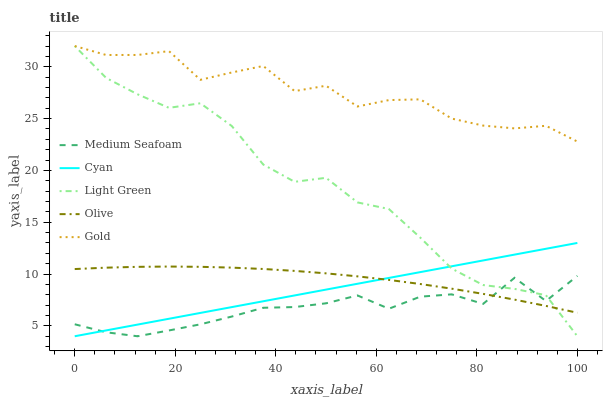Does Cyan have the minimum area under the curve?
Answer yes or no. No. Does Cyan have the maximum area under the curve?
Answer yes or no. No. Is Gold the smoothest?
Answer yes or no. No. Is Cyan the roughest?
Answer yes or no. No. Does Gold have the lowest value?
Answer yes or no. No. Does Cyan have the highest value?
Answer yes or no. No. Is Olive less than Gold?
Answer yes or no. Yes. Is Gold greater than Cyan?
Answer yes or no. Yes. Does Olive intersect Gold?
Answer yes or no. No. 